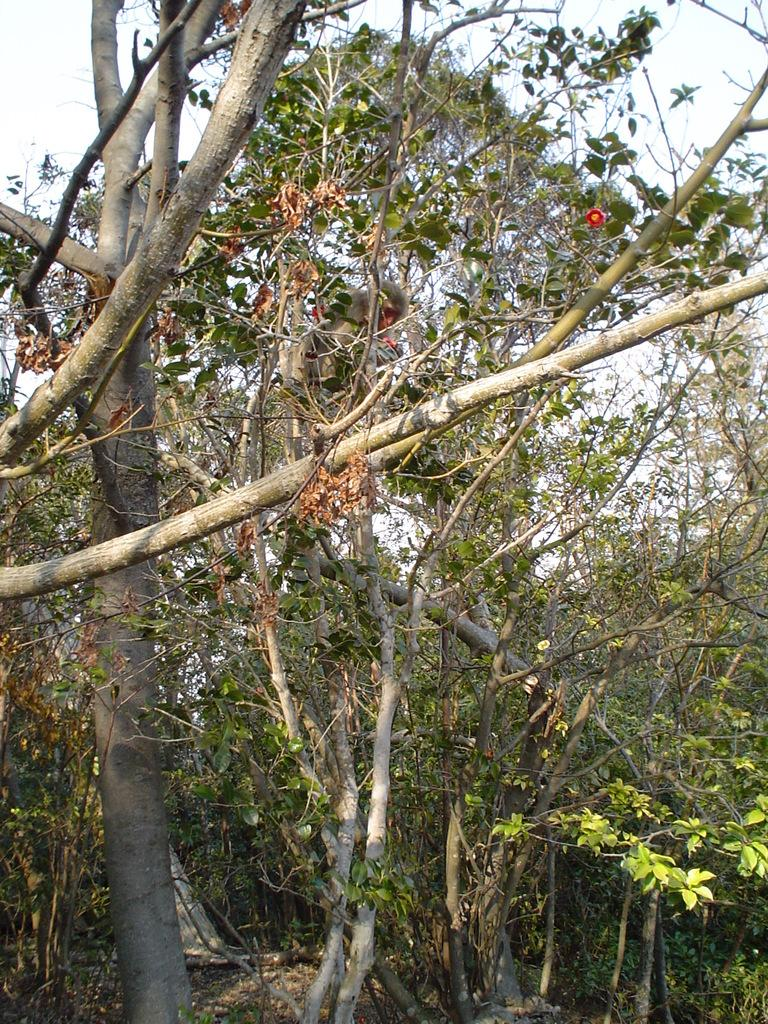What type of vegetation is present in the image? There are many trees in the image. What specific parts of the trees can be seen? The trees have branches and stems. What can be seen in the background of the image? There is a sky visible in the background of the image. What type of harbor can be seen in the image? There is no harbor present in the image; it features many trees with branches and stems, and a sky visible in the background. 